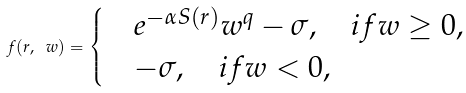<formula> <loc_0><loc_0><loc_500><loc_500>f ( r , \ w ) = \begin{cases} & e ^ { - \alpha S ( r ) } w ^ { q } - \sigma , \quad i f w \geq 0 , \\ & - \sigma , \quad i f w < 0 , \end{cases}</formula> 